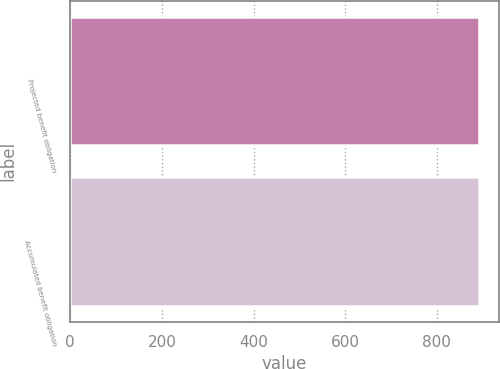Convert chart. <chart><loc_0><loc_0><loc_500><loc_500><bar_chart><fcel>Projected benefit obligation<fcel>Accumulated benefit obligation<nl><fcel>891<fcel>891.1<nl></chart> 